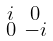<formula> <loc_0><loc_0><loc_500><loc_500>\begin{smallmatrix} i & 0 \\ 0 & - i \\ \end{smallmatrix}</formula> 